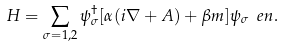<formula> <loc_0><loc_0><loc_500><loc_500>H = \sum _ { \sigma = 1 , 2 } \psi ^ { \dag } _ { \sigma } [ { \alpha ( i \nabla + A ) } + \beta m ] \psi _ { \sigma } \ e n .</formula> 